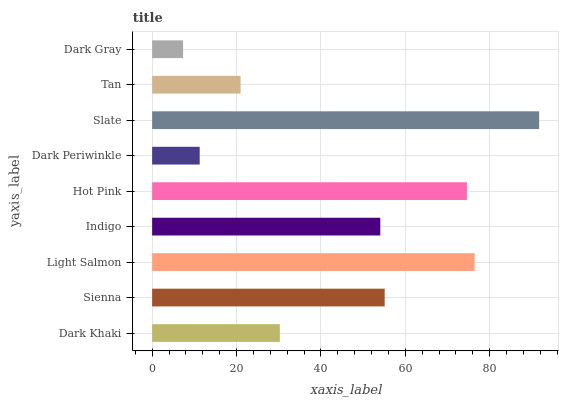Is Dark Gray the minimum?
Answer yes or no. Yes. Is Slate the maximum?
Answer yes or no. Yes. Is Sienna the minimum?
Answer yes or no. No. Is Sienna the maximum?
Answer yes or no. No. Is Sienna greater than Dark Khaki?
Answer yes or no. Yes. Is Dark Khaki less than Sienna?
Answer yes or no. Yes. Is Dark Khaki greater than Sienna?
Answer yes or no. No. Is Sienna less than Dark Khaki?
Answer yes or no. No. Is Indigo the high median?
Answer yes or no. Yes. Is Indigo the low median?
Answer yes or no. Yes. Is Sienna the high median?
Answer yes or no. No. Is Hot Pink the low median?
Answer yes or no. No. 